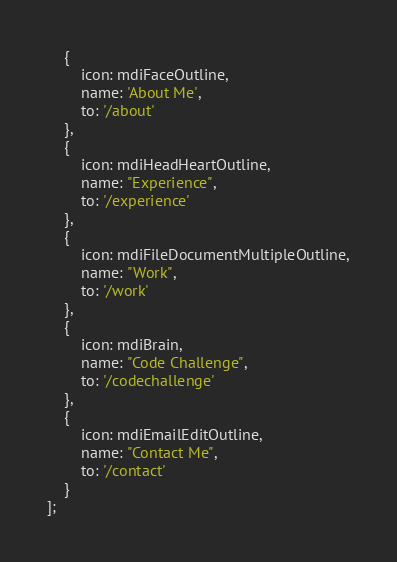Convert code to text. <code><loc_0><loc_0><loc_500><loc_500><_JavaScript_>    {
        icon: mdiFaceOutline,
        name: 'About Me',
        to: '/about'
    },
    {
        icon: mdiHeadHeartOutline,
        name: "Experience",
        to: '/experience'
    },
    {
        icon: mdiFileDocumentMultipleOutline,
        name: "Work",
        to: '/work'
    },
    {
        icon: mdiBrain,
        name: "Code Challenge",
        to: '/codechallenge'
    },
    {
        icon: mdiEmailEditOutline,
        name: "Contact Me",
        to: '/contact'
    }
];</code> 